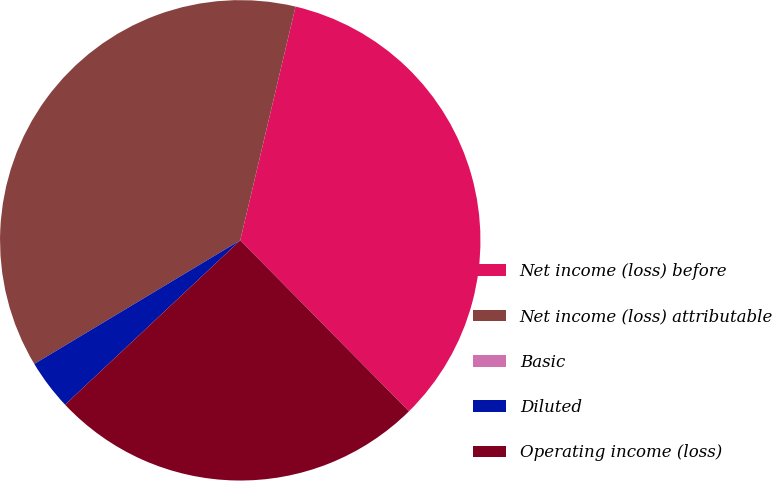Convert chart. <chart><loc_0><loc_0><loc_500><loc_500><pie_chart><fcel>Net income (loss) before<fcel>Net income (loss) attributable<fcel>Basic<fcel>Diluted<fcel>Operating income (loss)<nl><fcel>33.91%<fcel>37.3%<fcel>0.0%<fcel>3.39%<fcel>25.4%<nl></chart> 